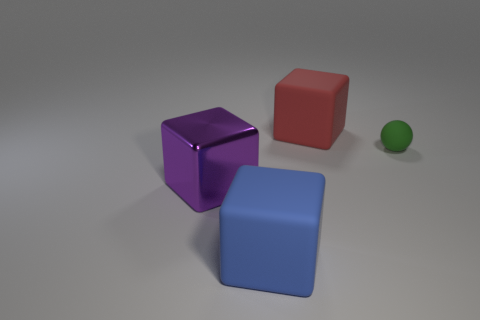Do the matte cube that is on the right side of the blue matte cube and the purple object have the same size?
Your answer should be very brief. Yes. There is a large thing that is right of the big rubber block that is in front of the sphere; how many big red blocks are to the left of it?
Ensure brevity in your answer.  0. What number of cyan things are either rubber objects or large things?
Your response must be concise. 0. The large block that is made of the same material as the big blue object is what color?
Provide a succinct answer. Red. Is there any other thing that has the same size as the red thing?
Make the answer very short. Yes. What number of large things are metal balls or purple cubes?
Offer a very short reply. 1. Is the number of green balls less than the number of small purple rubber things?
Ensure brevity in your answer.  No. The other large shiny object that is the same shape as the big blue thing is what color?
Your answer should be compact. Purple. Is there anything else that is the same shape as the green rubber thing?
Your answer should be very brief. No. Is the number of big blue matte things greater than the number of blocks?
Offer a terse response. No. 